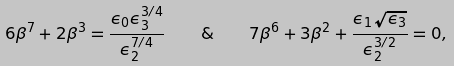Convert formula to latex. <formula><loc_0><loc_0><loc_500><loc_500>6 \beta ^ { 7 } + 2 \beta ^ { 3 } = \frac { \epsilon _ { 0 } \epsilon _ { 3 } ^ { 3 / 4 } } { \epsilon _ { 2 } ^ { 7 / 4 } } \quad \& \quad 7 \beta ^ { 6 } + 3 \beta ^ { 2 } + \frac { \epsilon _ { 1 } \sqrt { \epsilon _ { 3 } } } { \epsilon _ { 2 } ^ { 3 / 2 } } = 0 ,</formula> 